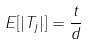<formula> <loc_0><loc_0><loc_500><loc_500>E [ | T _ { j } | ] = \frac { t } { d }</formula> 